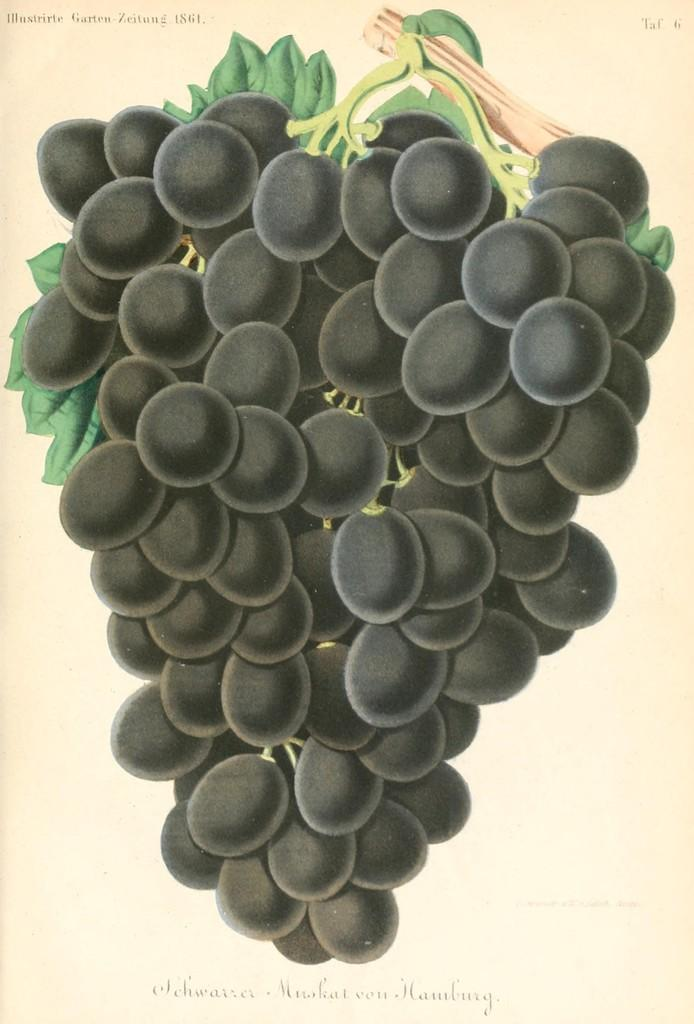What is the main subject of the image? The main subject of the image is a picture of a bunch of grapes. Are there any other objects or elements in the image besides the grapes? Yes, there are letters on a paper in the image. What type of cracker is being used to ask questions about the flowers in the image? There are no crackers, questions, or flowers present in the image. 